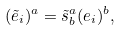Convert formula to latex. <formula><loc_0><loc_0><loc_500><loc_500>( \tilde { e } _ { i } ) ^ { a } = \tilde { s } ^ { a } _ { b } ( e _ { i } ) ^ { b } ,</formula> 